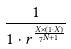<formula> <loc_0><loc_0><loc_500><loc_500>\frac { 1 } { 1 \cdot r ^ { \frac { X \times ( 1 \cdot X ) } { 7 ^ { N + 1 } } } }</formula> 